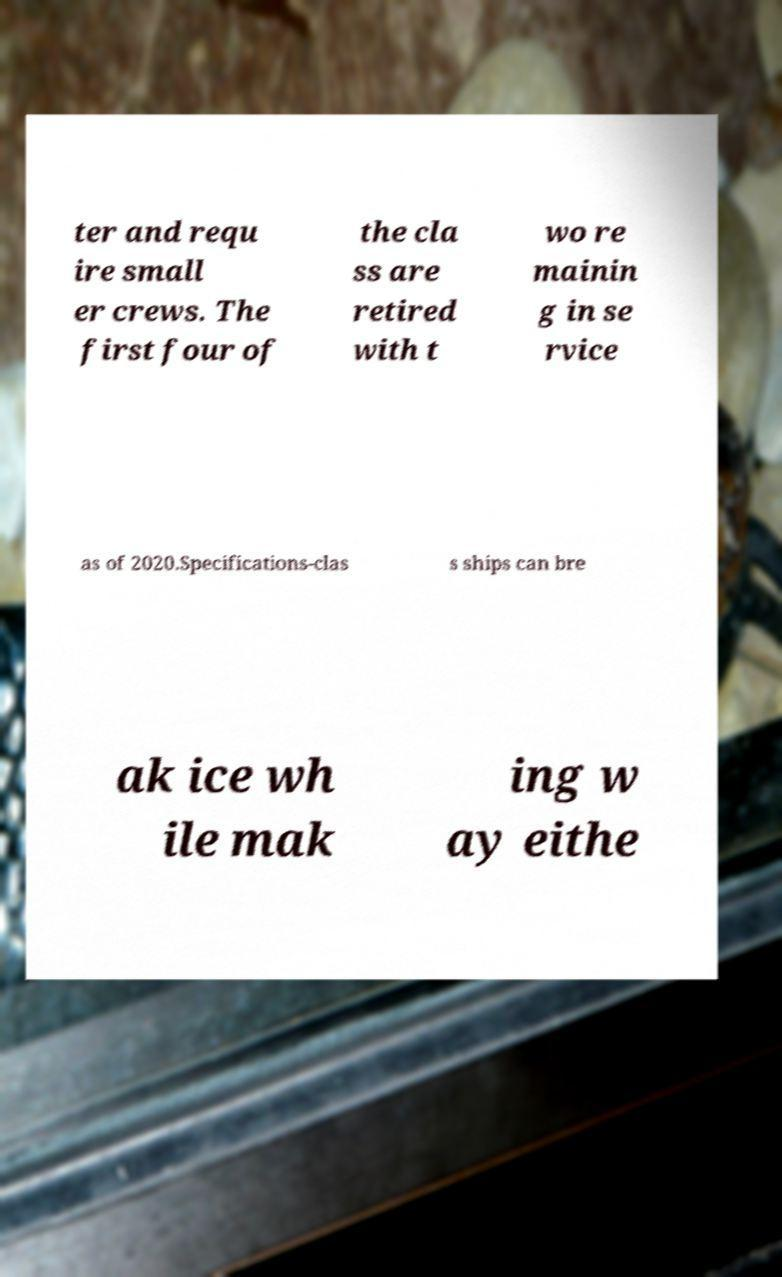Please identify and transcribe the text found in this image. ter and requ ire small er crews. The first four of the cla ss are retired with t wo re mainin g in se rvice as of 2020.Specifications-clas s ships can bre ak ice wh ile mak ing w ay eithe 